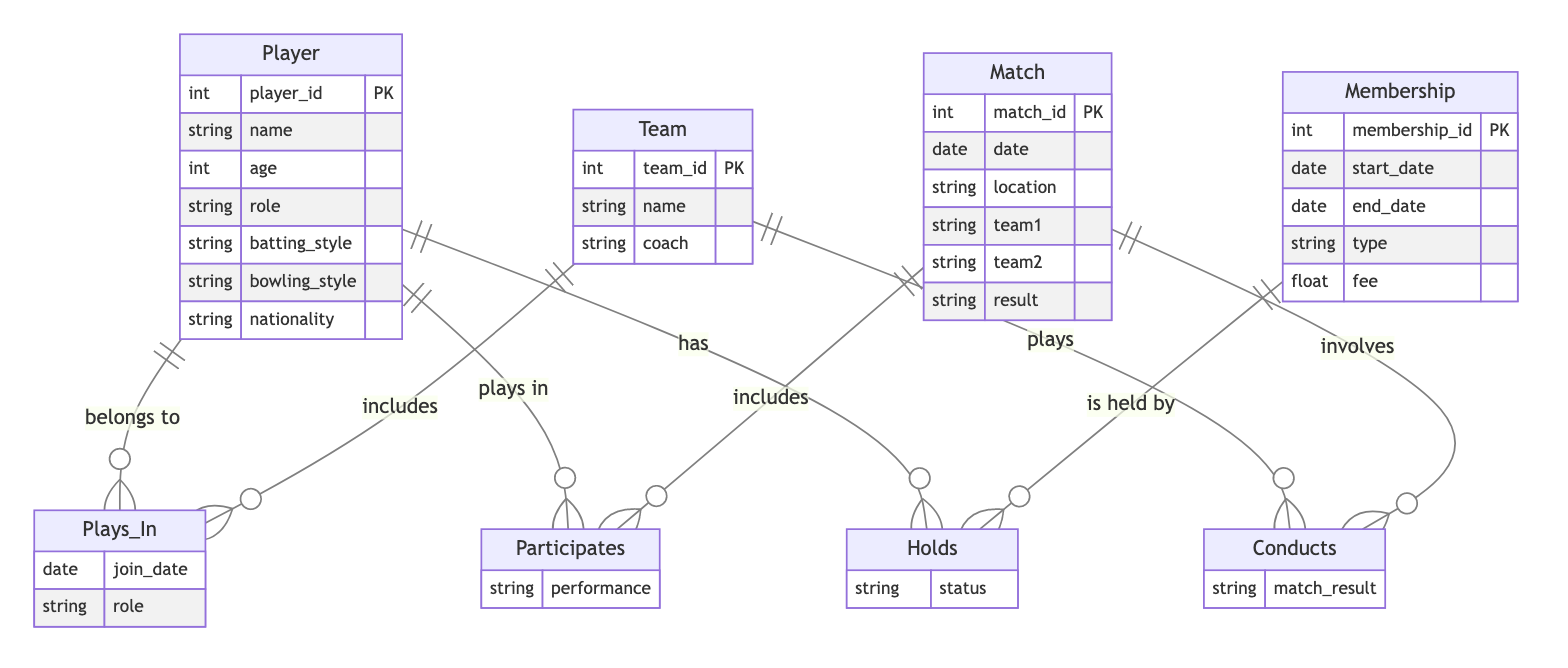What are the entities in this diagram? The diagram consists of four entities: Player, Match, Membership, and Team. Each entity represents a core component of the Local Cricket Club Management System.
Answer: Player, Match, Membership, Team How many attributes does the Player entity have? The Player entity has six attributes: player_id, name, age, role, batting_style, and bowling_style. This information is clearly listed under the Player entity in the diagram.
Answer: Six What is the relationship between Player and Match? The Player and Match entities are linked by the relationship named Participates, which indicates that players take part in matches. The diagram visually represents this relationship.
Answer: Participates What does the Holds relationship signify? The Holds relationship signifies that players have memberships. It connects the Player entity with the Membership entity, indicating the relationship between players and their membership details.
Answer: Membership How are teams connected to matches? Teams are connected to matches through the Conducts relationship, meaning teams are involved in conducting matches. This is indicated in the diagram by the direct association between Team and Match.
Answer: Conducts How many relationships exist in the diagram? There are four relationships depicted in the diagram: Plays_In, Participates, Conducts, and Holds. Each one connects entities in a way relevant to the cricket club's management system.
Answer: Four What type of attribute is 'fee' in the Membership entity? The 'fee' attribute in the Membership entity is of type float, representing the monetary value associated with the membership type. This is clear from the attribute list under Membership.
Answer: Float Which entity does the attribute 'match_result' belong to? The attribute 'match_result' belongs to the Conducts relationship, which is outlined between the Team and Match entities, indicating the result of the match conducted by a team.
Answer: Conducts What information does the 'performance' attribute in Participates represent? The 'performance' attribute in the Participates relationship represents the level or metrics of players' performances in matches, linking Player to Match entities. This indicates how players contribute in a match context.
Answer: Performance 